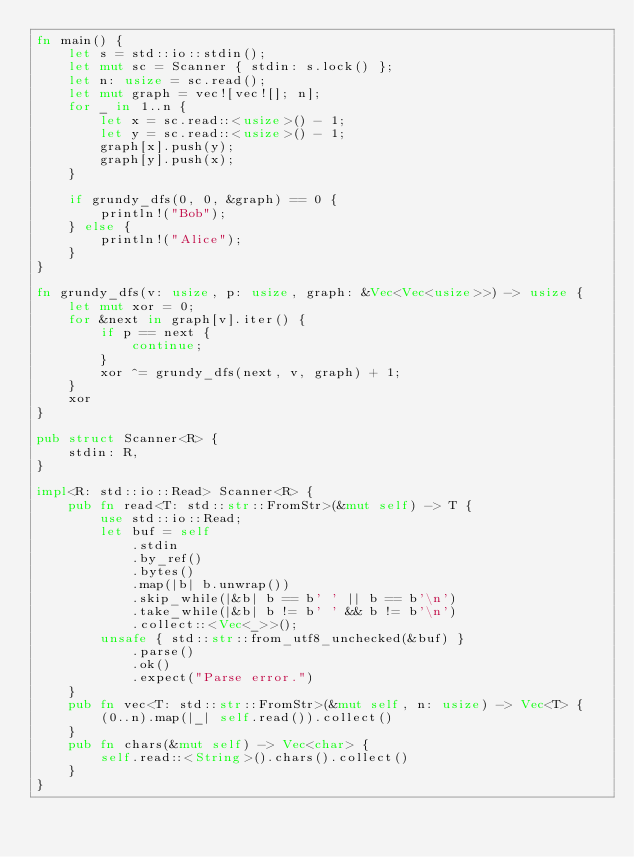<code> <loc_0><loc_0><loc_500><loc_500><_Rust_>fn main() {
    let s = std::io::stdin();
    let mut sc = Scanner { stdin: s.lock() };
    let n: usize = sc.read();
    let mut graph = vec![vec![]; n];
    for _ in 1..n {
        let x = sc.read::<usize>() - 1;
        let y = sc.read::<usize>() - 1;
        graph[x].push(y);
        graph[y].push(x);
    }

    if grundy_dfs(0, 0, &graph) == 0 {
        println!("Bob");
    } else {
        println!("Alice");
    }
}

fn grundy_dfs(v: usize, p: usize, graph: &Vec<Vec<usize>>) -> usize {
    let mut xor = 0;
    for &next in graph[v].iter() {
        if p == next {
            continue;
        }
        xor ^= grundy_dfs(next, v, graph) + 1;
    }
    xor
}

pub struct Scanner<R> {
    stdin: R,
}

impl<R: std::io::Read> Scanner<R> {
    pub fn read<T: std::str::FromStr>(&mut self) -> T {
        use std::io::Read;
        let buf = self
            .stdin
            .by_ref()
            .bytes()
            .map(|b| b.unwrap())
            .skip_while(|&b| b == b' ' || b == b'\n')
            .take_while(|&b| b != b' ' && b != b'\n')
            .collect::<Vec<_>>();
        unsafe { std::str::from_utf8_unchecked(&buf) }
            .parse()
            .ok()
            .expect("Parse error.")
    }
    pub fn vec<T: std::str::FromStr>(&mut self, n: usize) -> Vec<T> {
        (0..n).map(|_| self.read()).collect()
    }
    pub fn chars(&mut self) -> Vec<char> {
        self.read::<String>().chars().collect()
    }
}
</code> 